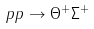<formula> <loc_0><loc_0><loc_500><loc_500>p p \to \Theta ^ { + } \Sigma ^ { + }</formula> 